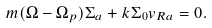<formula> <loc_0><loc_0><loc_500><loc_500>m ( \Omega - \Omega _ { p } ) \Sigma _ { a } + k \Sigma _ { 0 } v _ { R a } = 0 .</formula> 